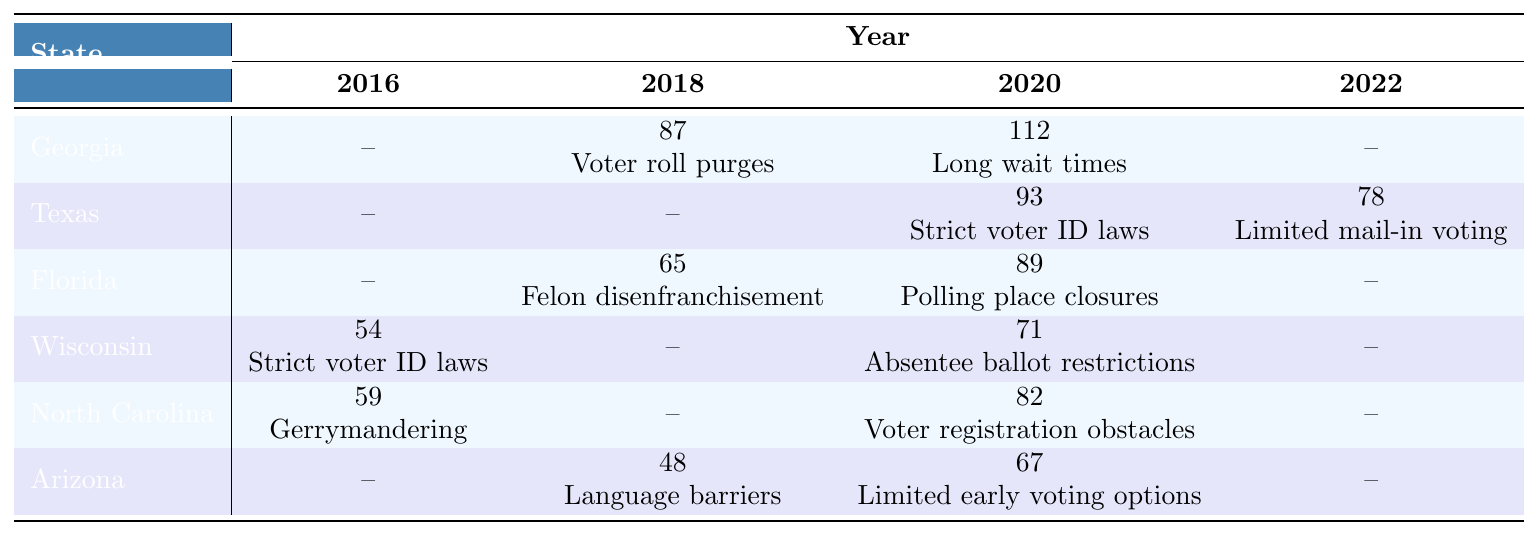What was the primary issue reported in Georgia in 2018? The table indicates that in Georgia during 2018, the primary issue reported was "Voter roll purges."
Answer: Voter roll purges How many incidents of voter suppression were reported in Florida in 2020? According to the table, there were 89 incidents of voter suppression reported in Florida in 2020.
Answer: 89 Which state reported the highest number of voter suppression incidents in 2020? The table shows that Georgia had the highest number of incidents in 2020 (112), followed by Texas (93) and Florida (89).
Answer: Georgia What was the primary issue associated with voter suppression in Texas in 2022? In 2022, the primary issue reported for voter suppression in Texas was "Limited mail-in voting."
Answer: Limited mail-in voting In which state were there 54 reported incidents of voter suppression in 2016? The table reveals that Wisconsin had 54 reported incidents in 2016, which were due to "Strict voter ID laws."
Answer: Wisconsin How many total incidents of voter suppression were reported for Georgia across all years listed? Summing the incidents for Georgia: 87 (2018) + 112 (2020) = 199. Georgia had no reported incidents in 2016 and 2022, so the total is 199.
Answer: 199 True or False: Arizona had more reported incidents of voter suppression in 2020 than North Carolina. The table shows Arizona had 67 incidents in 2020, while North Carolina had 82 incidents. Therefore, the statement is false.
Answer: False What trend can be observed regarding voter suppression incidents in Texas from 2020 to 2022? The number of incidents decreased from 93 in 2020 to 78 in 2022, indicating a downward trend in reported voter suppression incidents.
Answer: Downward trend Which state had the primary issue of "Voter registration obstacles" and how many incidents occurred? The state of North Carolina had this issue reported in 2020 with 82 incidents.
Answer: North Carolina, 82 incidents Calculate the average number of incidents of voter suppression across all states for the year 2020. For 2020, the total incidents are 112 (Georgia) + 93 (Texas) + 89 (Florida) + 71 (Wisconsin) + 82 (North Carolina) + 67 (Arizona) = 514. There are 6 states, so the average is 514/6 ≈ 85.67.
Answer: 85.67 